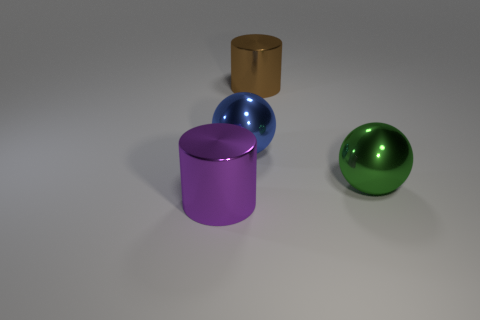There is a large cylinder that is on the left side of the metallic cylinder right of the blue object; what is its material?
Make the answer very short. Metal. What shape is the big brown object that is the same material as the large green object?
Keep it short and to the point. Cylinder. What is the color of the shiny sphere right of the metallic cylinder right of the purple metal object?
Ensure brevity in your answer.  Green. What material is the ball to the left of the brown shiny cylinder that is behind the large blue metallic sphere behind the large green metallic object made of?
Offer a very short reply. Metal. How many metallic objects are the same size as the green sphere?
Your answer should be very brief. 3. There is a big thing that is both behind the large green ball and on the right side of the blue metal sphere; what is it made of?
Offer a very short reply. Metal. There is a big green metallic sphere; what number of objects are in front of it?
Your answer should be compact. 1. Does the green shiny object have the same shape as the large blue metallic object that is on the left side of the big green thing?
Keep it short and to the point. Yes. Is there a blue shiny thing of the same shape as the green thing?
Provide a succinct answer. Yes. There is a large purple shiny thing left of the big cylinder that is behind the big purple thing; what shape is it?
Ensure brevity in your answer.  Cylinder. 